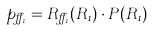Convert formula to latex. <formula><loc_0><loc_0><loc_500><loc_500>p _ { \alpha _ { 1 } } = { R } _ { \alpha _ { 1 } } ( R _ { 1 } ) \cdot { P } ( R _ { 1 } )</formula> 